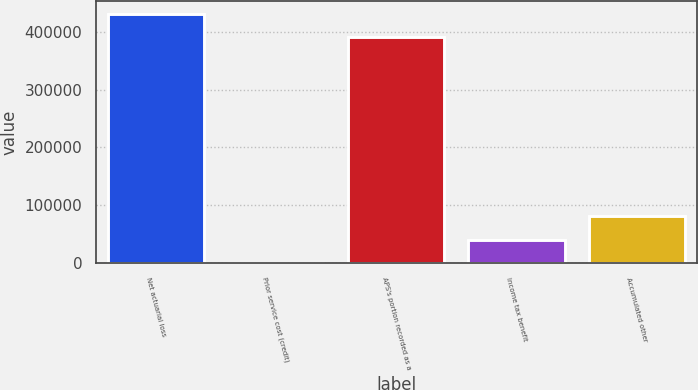Convert chart to OTSL. <chart><loc_0><loc_0><loc_500><loc_500><bar_chart><fcel>Net actuarial loss<fcel>Prior service cost (credit)<fcel>APS's portion recorded as a<fcel>Income tax benefit<fcel>Accumulated other<nl><fcel>430545<fcel>655<fcel>390521<fcel>40678.7<fcel>80702.4<nl></chart> 